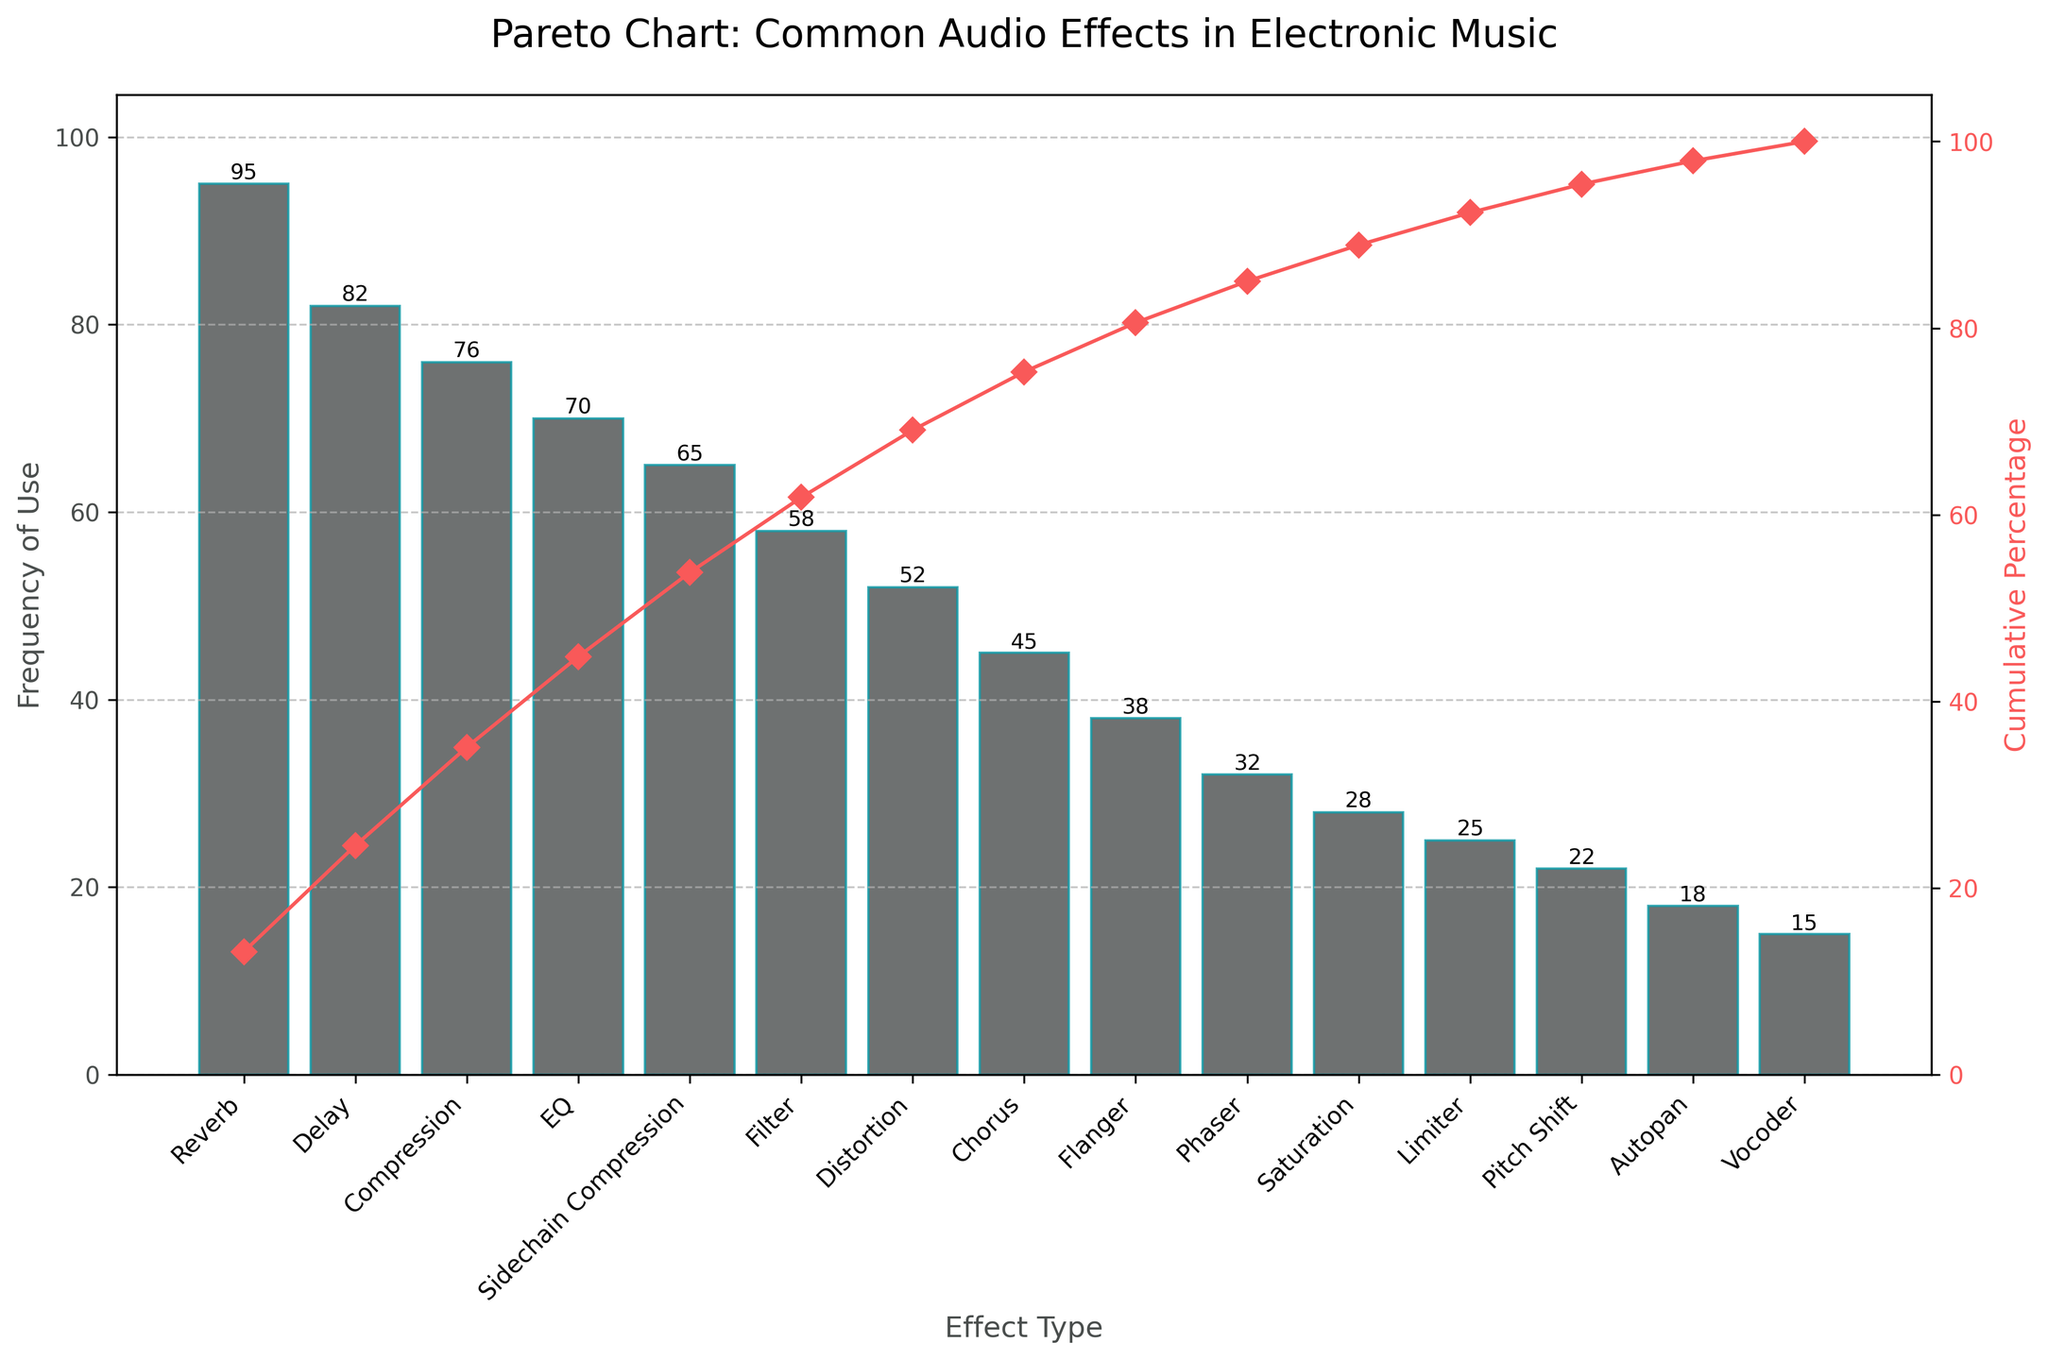How many effect types are represented in the pareto chart? Count the number of bars in the bar chart, each bar represents one effect type.
Answer: 15 Which audio effect is used the most in electronic music? Identify the tallest bar in the bar chart and read the corresponding label.
Answer: Reverb What is the cumulative percentage when the cumulative frequency reaches 200? Find the data points on the cumulative percentage line where the sum of the frequencies of the bars up to that point adds up to 200. Sum of frequencies for Reverb, Delay, and Compression: 95 + 82 + 76 = 253. At Delay (95 + 82 = 177) is closest under, so next one.
Answer: 72.27% What is the difference in frequency of use between the most and least used audio effects? Subtract the frequency of the least used effect (Vocoder) from the frequency of the most used effect (Reverb). 95 - 15 = 80
Answer: 80 Which two audio effects have the closest frequencies of use? Look for bars with similar heights and ensure their usage counts are nearest. Compression (76) and EQ (70) have the closest usage counts since 76 - 70 = 6.
Answer: Compression and EQ Between Reverb and Delay, what is the cumulative percentage of use? Add the frequencies of Reverb and Delay, then calculate their percentage of the total frequency. Cumulative value = 95 + 82 = 177. Percentage = (177 / 721) * 100%
Answer: 24.54% How many audio effects have a usage frequency greater than 50? Count the number of bars with a height representing a frequency greater than 50. Reverb, Delay, Compression, EQ, Sidechain Compression, Filter, Distortion.
Answer: 7 How does the height of the Bar for Chorus compare to the height of the Bar for Phaser? Compare their usage frequencies, with Chorus being 45 and Phaser being 32. 45 > 32
Answer: Chorus is taller What is the cumulative percentage when you include the top 5 most common audio effects? Add the frequencies of the top 5 most common effects, then calculate the cumulative percentage. Top 5 effects: Reverb (95), Delay (82), Compression (76), EQ (70), Sidechain Compression (65) Sum = 95 + 82 + 76 + 70 + 65 = 388. Cumulative Percentage = (388 / 721) * 100%
Answer: 53.82% What is the frequency of the second least common audio effect? Identify the second shortest bar and read the corresponding label. Pitch Shift has a frequency of 22, one above Vocoder with 15.
Answer: 22 